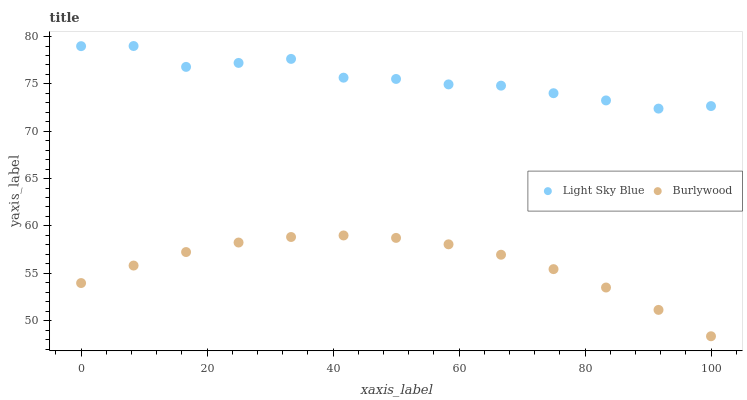Does Burlywood have the minimum area under the curve?
Answer yes or no. Yes. Does Light Sky Blue have the maximum area under the curve?
Answer yes or no. Yes. Does Light Sky Blue have the minimum area under the curve?
Answer yes or no. No. Is Burlywood the smoothest?
Answer yes or no. Yes. Is Light Sky Blue the roughest?
Answer yes or no. Yes. Is Light Sky Blue the smoothest?
Answer yes or no. No. Does Burlywood have the lowest value?
Answer yes or no. Yes. Does Light Sky Blue have the lowest value?
Answer yes or no. No. Does Light Sky Blue have the highest value?
Answer yes or no. Yes. Is Burlywood less than Light Sky Blue?
Answer yes or no. Yes. Is Light Sky Blue greater than Burlywood?
Answer yes or no. Yes. Does Burlywood intersect Light Sky Blue?
Answer yes or no. No. 